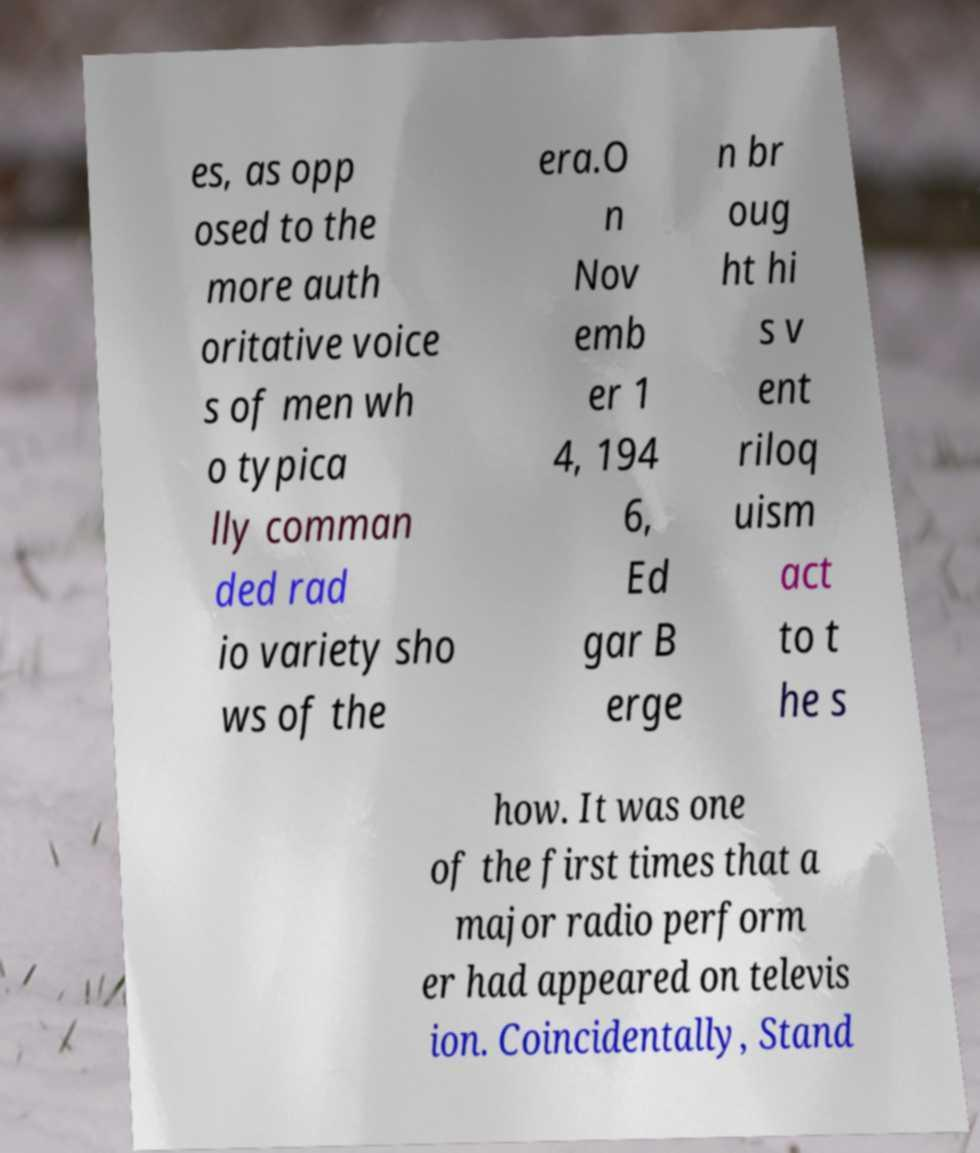Please read and relay the text visible in this image. What does it say? es, as opp osed to the more auth oritative voice s of men wh o typica lly comman ded rad io variety sho ws of the era.O n Nov emb er 1 4, 194 6, Ed gar B erge n br oug ht hi s v ent riloq uism act to t he s how. It was one of the first times that a major radio perform er had appeared on televis ion. Coincidentally, Stand 